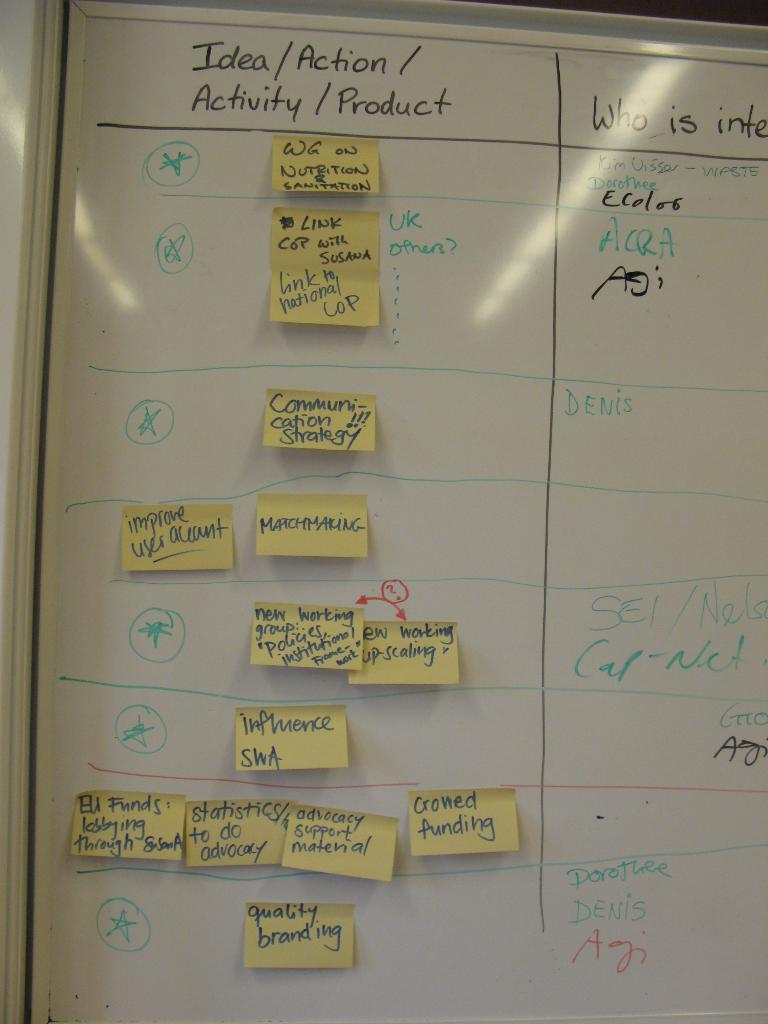<image>
Create a compact narrative representing the image presented. Chart on white board with Sticky notes attached under the header "Idea/Action/Activity/Product". 